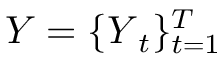<formula> <loc_0><loc_0><loc_500><loc_500>Y = \{ Y _ { t } \} _ { t = 1 } ^ { T }</formula> 